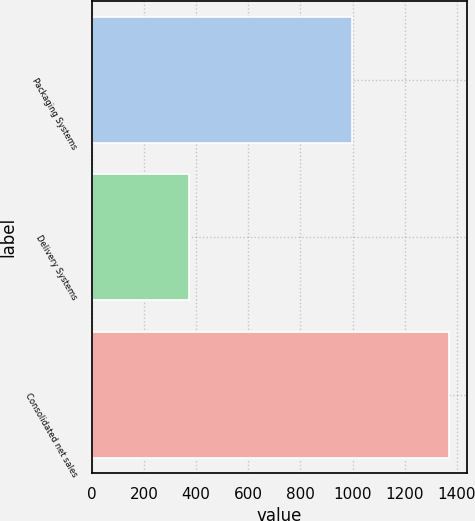Convert chart to OTSL. <chart><loc_0><loc_0><loc_500><loc_500><bar_chart><fcel>Packaging Systems<fcel>Delivery Systems<fcel>Consolidated net sales<nl><fcel>996<fcel>374.1<fcel>1368.4<nl></chart> 